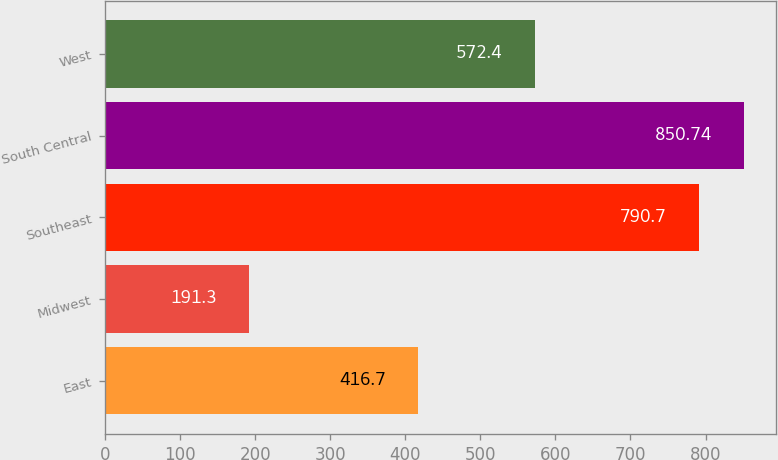<chart> <loc_0><loc_0><loc_500><loc_500><bar_chart><fcel>East<fcel>Midwest<fcel>Southeast<fcel>South Central<fcel>West<nl><fcel>416.7<fcel>191.3<fcel>790.7<fcel>850.74<fcel>572.4<nl></chart> 